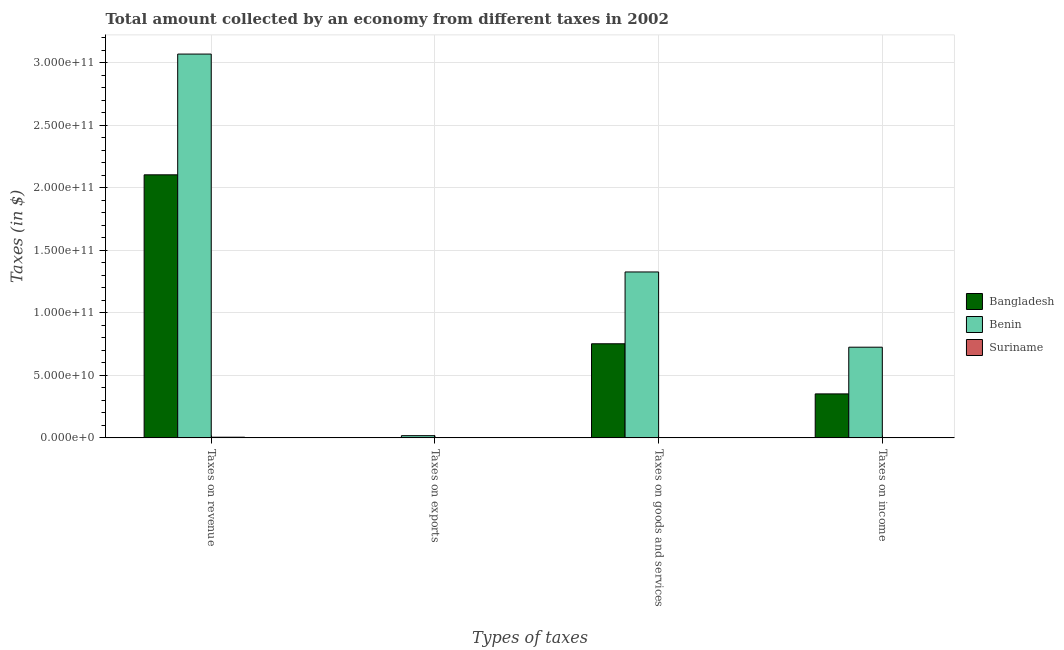How many different coloured bars are there?
Provide a short and direct response. 3. How many groups of bars are there?
Provide a succinct answer. 4. Are the number of bars per tick equal to the number of legend labels?
Your answer should be very brief. Yes. Are the number of bars on each tick of the X-axis equal?
Your response must be concise. Yes. How many bars are there on the 4th tick from the left?
Provide a succinct answer. 3. How many bars are there on the 4th tick from the right?
Provide a succinct answer. 3. What is the label of the 1st group of bars from the left?
Provide a succinct answer. Taxes on revenue. What is the amount collected as tax on income in Benin?
Give a very brief answer. 7.25e+1. Across all countries, what is the maximum amount collected as tax on goods?
Offer a terse response. 1.33e+11. Across all countries, what is the minimum amount collected as tax on goods?
Keep it short and to the point. 1.86e+08. In which country was the amount collected as tax on exports maximum?
Make the answer very short. Benin. In which country was the amount collected as tax on income minimum?
Offer a terse response. Suriname. What is the total amount collected as tax on goods in the graph?
Provide a succinct answer. 2.08e+11. What is the difference between the amount collected as tax on revenue in Suriname and that in Benin?
Keep it short and to the point. -3.06e+11. What is the difference between the amount collected as tax on goods in Bangladesh and the amount collected as tax on exports in Suriname?
Your answer should be very brief. 7.52e+1. What is the average amount collected as tax on exports per country?
Offer a terse response. 5.90e+08. What is the difference between the amount collected as tax on goods and amount collected as tax on income in Suriname?
Offer a very short reply. -3.04e+06. In how many countries, is the amount collected as tax on exports greater than 300000000000 $?
Your answer should be very brief. 0. What is the ratio of the amount collected as tax on goods in Bangladesh to that in Suriname?
Your answer should be very brief. 404.92. Is the difference between the amount collected as tax on goods in Suriname and Benin greater than the difference between the amount collected as tax on revenue in Suriname and Benin?
Offer a terse response. Yes. What is the difference between the highest and the second highest amount collected as tax on income?
Offer a terse response. 3.73e+1. What is the difference between the highest and the lowest amount collected as tax on income?
Give a very brief answer. 7.23e+1. Is it the case that in every country, the sum of the amount collected as tax on goods and amount collected as tax on revenue is greater than the sum of amount collected as tax on income and amount collected as tax on exports?
Make the answer very short. No. What does the 3rd bar from the left in Taxes on income represents?
Offer a very short reply. Suriname. What does the 1st bar from the right in Taxes on income represents?
Give a very brief answer. Suriname. How many bars are there?
Ensure brevity in your answer.  12. Are all the bars in the graph horizontal?
Your answer should be very brief. No. What is the difference between two consecutive major ticks on the Y-axis?
Your answer should be very brief. 5.00e+1. Are the values on the major ticks of Y-axis written in scientific E-notation?
Ensure brevity in your answer.  Yes. How are the legend labels stacked?
Keep it short and to the point. Vertical. What is the title of the graph?
Your answer should be very brief. Total amount collected by an economy from different taxes in 2002. What is the label or title of the X-axis?
Your answer should be very brief. Types of taxes. What is the label or title of the Y-axis?
Offer a very short reply. Taxes (in $). What is the Taxes (in $) of Bangladesh in Taxes on revenue?
Ensure brevity in your answer.  2.10e+11. What is the Taxes (in $) in Benin in Taxes on revenue?
Provide a short and direct response. 3.07e+11. What is the Taxes (in $) of Suriname in Taxes on revenue?
Your answer should be very brief. 5.24e+08. What is the Taxes (in $) in Benin in Taxes on exports?
Your response must be concise. 1.77e+09. What is the Taxes (in $) of Suriname in Taxes on exports?
Your answer should be very brief. 4.93e+06. What is the Taxes (in $) in Bangladesh in Taxes on goods and services?
Provide a succinct answer. 7.52e+1. What is the Taxes (in $) in Benin in Taxes on goods and services?
Make the answer very short. 1.33e+11. What is the Taxes (in $) of Suriname in Taxes on goods and services?
Your answer should be very brief. 1.86e+08. What is the Taxes (in $) in Bangladesh in Taxes on income?
Provide a succinct answer. 3.52e+1. What is the Taxes (in $) in Benin in Taxes on income?
Keep it short and to the point. 7.25e+1. What is the Taxes (in $) in Suriname in Taxes on income?
Offer a terse response. 1.89e+08. Across all Types of taxes, what is the maximum Taxes (in $) of Bangladesh?
Offer a terse response. 2.10e+11. Across all Types of taxes, what is the maximum Taxes (in $) of Benin?
Provide a short and direct response. 3.07e+11. Across all Types of taxes, what is the maximum Taxes (in $) in Suriname?
Your answer should be very brief. 5.24e+08. Across all Types of taxes, what is the minimum Taxes (in $) of Bangladesh?
Offer a terse response. 10000. Across all Types of taxes, what is the minimum Taxes (in $) in Benin?
Provide a succinct answer. 1.77e+09. Across all Types of taxes, what is the minimum Taxes (in $) of Suriname?
Offer a terse response. 4.93e+06. What is the total Taxes (in $) of Bangladesh in the graph?
Keep it short and to the point. 3.21e+11. What is the total Taxes (in $) of Benin in the graph?
Your response must be concise. 5.14e+11. What is the total Taxes (in $) in Suriname in the graph?
Offer a terse response. 9.04e+08. What is the difference between the Taxes (in $) of Bangladesh in Taxes on revenue and that in Taxes on exports?
Ensure brevity in your answer.  2.10e+11. What is the difference between the Taxes (in $) of Benin in Taxes on revenue and that in Taxes on exports?
Provide a succinct answer. 3.05e+11. What is the difference between the Taxes (in $) in Suriname in Taxes on revenue and that in Taxes on exports?
Provide a short and direct response. 5.19e+08. What is the difference between the Taxes (in $) of Bangladesh in Taxes on revenue and that in Taxes on goods and services?
Ensure brevity in your answer.  1.35e+11. What is the difference between the Taxes (in $) of Benin in Taxes on revenue and that in Taxes on goods and services?
Give a very brief answer. 1.74e+11. What is the difference between the Taxes (in $) of Suriname in Taxes on revenue and that in Taxes on goods and services?
Keep it short and to the point. 3.38e+08. What is the difference between the Taxes (in $) in Bangladesh in Taxes on revenue and that in Taxes on income?
Offer a terse response. 1.75e+11. What is the difference between the Taxes (in $) of Benin in Taxes on revenue and that in Taxes on income?
Make the answer very short. 2.34e+11. What is the difference between the Taxes (in $) in Suriname in Taxes on revenue and that in Taxes on income?
Your answer should be compact. 3.35e+08. What is the difference between the Taxes (in $) of Bangladesh in Taxes on exports and that in Taxes on goods and services?
Your response must be concise. -7.52e+1. What is the difference between the Taxes (in $) in Benin in Taxes on exports and that in Taxes on goods and services?
Your response must be concise. -1.31e+11. What is the difference between the Taxes (in $) of Suriname in Taxes on exports and that in Taxes on goods and services?
Offer a terse response. -1.81e+08. What is the difference between the Taxes (in $) in Bangladesh in Taxes on exports and that in Taxes on income?
Your answer should be very brief. -3.52e+1. What is the difference between the Taxes (in $) in Benin in Taxes on exports and that in Taxes on income?
Provide a succinct answer. -7.07e+1. What is the difference between the Taxes (in $) of Suriname in Taxes on exports and that in Taxes on income?
Provide a short and direct response. -1.84e+08. What is the difference between the Taxes (in $) in Bangladesh in Taxes on goods and services and that in Taxes on income?
Your response must be concise. 4.01e+1. What is the difference between the Taxes (in $) of Benin in Taxes on goods and services and that in Taxes on income?
Your answer should be very brief. 6.01e+1. What is the difference between the Taxes (in $) in Suriname in Taxes on goods and services and that in Taxes on income?
Provide a short and direct response. -3.04e+06. What is the difference between the Taxes (in $) in Bangladesh in Taxes on revenue and the Taxes (in $) in Benin in Taxes on exports?
Give a very brief answer. 2.09e+11. What is the difference between the Taxes (in $) of Bangladesh in Taxes on revenue and the Taxes (in $) of Suriname in Taxes on exports?
Your answer should be very brief. 2.10e+11. What is the difference between the Taxes (in $) of Benin in Taxes on revenue and the Taxes (in $) of Suriname in Taxes on exports?
Your response must be concise. 3.07e+11. What is the difference between the Taxes (in $) in Bangladesh in Taxes on revenue and the Taxes (in $) in Benin in Taxes on goods and services?
Offer a terse response. 7.77e+1. What is the difference between the Taxes (in $) in Bangladesh in Taxes on revenue and the Taxes (in $) in Suriname in Taxes on goods and services?
Offer a terse response. 2.10e+11. What is the difference between the Taxes (in $) in Benin in Taxes on revenue and the Taxes (in $) in Suriname in Taxes on goods and services?
Provide a succinct answer. 3.07e+11. What is the difference between the Taxes (in $) of Bangladesh in Taxes on revenue and the Taxes (in $) of Benin in Taxes on income?
Provide a succinct answer. 1.38e+11. What is the difference between the Taxes (in $) of Bangladesh in Taxes on revenue and the Taxes (in $) of Suriname in Taxes on income?
Offer a terse response. 2.10e+11. What is the difference between the Taxes (in $) of Benin in Taxes on revenue and the Taxes (in $) of Suriname in Taxes on income?
Offer a terse response. 3.07e+11. What is the difference between the Taxes (in $) in Bangladesh in Taxes on exports and the Taxes (in $) in Benin in Taxes on goods and services?
Your response must be concise. -1.33e+11. What is the difference between the Taxes (in $) of Bangladesh in Taxes on exports and the Taxes (in $) of Suriname in Taxes on goods and services?
Provide a succinct answer. -1.86e+08. What is the difference between the Taxes (in $) of Benin in Taxes on exports and the Taxes (in $) of Suriname in Taxes on goods and services?
Provide a succinct answer. 1.58e+09. What is the difference between the Taxes (in $) in Bangladesh in Taxes on exports and the Taxes (in $) in Benin in Taxes on income?
Make the answer very short. -7.25e+1. What is the difference between the Taxes (in $) of Bangladesh in Taxes on exports and the Taxes (in $) of Suriname in Taxes on income?
Ensure brevity in your answer.  -1.89e+08. What is the difference between the Taxes (in $) in Benin in Taxes on exports and the Taxes (in $) in Suriname in Taxes on income?
Your response must be concise. 1.58e+09. What is the difference between the Taxes (in $) of Bangladesh in Taxes on goods and services and the Taxes (in $) of Benin in Taxes on income?
Provide a succinct answer. 2.73e+09. What is the difference between the Taxes (in $) of Bangladesh in Taxes on goods and services and the Taxes (in $) of Suriname in Taxes on income?
Ensure brevity in your answer.  7.50e+1. What is the difference between the Taxes (in $) of Benin in Taxes on goods and services and the Taxes (in $) of Suriname in Taxes on income?
Your answer should be compact. 1.32e+11. What is the average Taxes (in $) in Bangladesh per Types of taxes?
Offer a very short reply. 8.02e+1. What is the average Taxes (in $) in Benin per Types of taxes?
Offer a terse response. 1.28e+11. What is the average Taxes (in $) of Suriname per Types of taxes?
Offer a terse response. 2.26e+08. What is the difference between the Taxes (in $) in Bangladesh and Taxes (in $) in Benin in Taxes on revenue?
Keep it short and to the point. -9.65e+1. What is the difference between the Taxes (in $) in Bangladesh and Taxes (in $) in Suriname in Taxes on revenue?
Your answer should be compact. 2.10e+11. What is the difference between the Taxes (in $) in Benin and Taxes (in $) in Suriname in Taxes on revenue?
Your answer should be compact. 3.06e+11. What is the difference between the Taxes (in $) in Bangladesh and Taxes (in $) in Benin in Taxes on exports?
Your response must be concise. -1.77e+09. What is the difference between the Taxes (in $) in Bangladesh and Taxes (in $) in Suriname in Taxes on exports?
Ensure brevity in your answer.  -4.92e+06. What is the difference between the Taxes (in $) of Benin and Taxes (in $) of Suriname in Taxes on exports?
Your response must be concise. 1.76e+09. What is the difference between the Taxes (in $) in Bangladesh and Taxes (in $) in Benin in Taxes on goods and services?
Make the answer very short. -5.74e+1. What is the difference between the Taxes (in $) of Bangladesh and Taxes (in $) of Suriname in Taxes on goods and services?
Your answer should be compact. 7.50e+1. What is the difference between the Taxes (in $) in Benin and Taxes (in $) in Suriname in Taxes on goods and services?
Keep it short and to the point. 1.32e+11. What is the difference between the Taxes (in $) of Bangladesh and Taxes (in $) of Benin in Taxes on income?
Your answer should be very brief. -3.73e+1. What is the difference between the Taxes (in $) of Bangladesh and Taxes (in $) of Suriname in Taxes on income?
Ensure brevity in your answer.  3.50e+1. What is the difference between the Taxes (in $) of Benin and Taxes (in $) of Suriname in Taxes on income?
Make the answer very short. 7.23e+1. What is the ratio of the Taxes (in $) in Bangladesh in Taxes on revenue to that in Taxes on exports?
Your answer should be compact. 2.10e+07. What is the ratio of the Taxes (in $) in Benin in Taxes on revenue to that in Taxes on exports?
Your answer should be compact. 173.83. What is the ratio of the Taxes (in $) in Suriname in Taxes on revenue to that in Taxes on exports?
Provide a succinct answer. 106.28. What is the ratio of the Taxes (in $) in Bangladesh in Taxes on revenue to that in Taxes on goods and services?
Offer a terse response. 2.8. What is the ratio of the Taxes (in $) in Benin in Taxes on revenue to that in Taxes on goods and services?
Your response must be concise. 2.31. What is the ratio of the Taxes (in $) in Suriname in Taxes on revenue to that in Taxes on goods and services?
Your response must be concise. 2.82. What is the ratio of the Taxes (in $) of Bangladesh in Taxes on revenue to that in Taxes on income?
Your answer should be compact. 5.98. What is the ratio of the Taxes (in $) in Benin in Taxes on revenue to that in Taxes on income?
Your response must be concise. 4.23. What is the ratio of the Taxes (in $) in Suriname in Taxes on revenue to that in Taxes on income?
Give a very brief answer. 2.78. What is the ratio of the Taxes (in $) in Bangladesh in Taxes on exports to that in Taxes on goods and services?
Offer a terse response. 0. What is the ratio of the Taxes (in $) of Benin in Taxes on exports to that in Taxes on goods and services?
Provide a succinct answer. 0.01. What is the ratio of the Taxes (in $) of Suriname in Taxes on exports to that in Taxes on goods and services?
Offer a terse response. 0.03. What is the ratio of the Taxes (in $) of Bangladesh in Taxes on exports to that in Taxes on income?
Your response must be concise. 0. What is the ratio of the Taxes (in $) of Benin in Taxes on exports to that in Taxes on income?
Make the answer very short. 0.02. What is the ratio of the Taxes (in $) of Suriname in Taxes on exports to that in Taxes on income?
Offer a very short reply. 0.03. What is the ratio of the Taxes (in $) in Bangladesh in Taxes on goods and services to that in Taxes on income?
Your response must be concise. 2.14. What is the ratio of the Taxes (in $) in Benin in Taxes on goods and services to that in Taxes on income?
Keep it short and to the point. 1.83. What is the ratio of the Taxes (in $) of Suriname in Taxes on goods and services to that in Taxes on income?
Keep it short and to the point. 0.98. What is the difference between the highest and the second highest Taxes (in $) in Bangladesh?
Provide a short and direct response. 1.35e+11. What is the difference between the highest and the second highest Taxes (in $) of Benin?
Your answer should be compact. 1.74e+11. What is the difference between the highest and the second highest Taxes (in $) in Suriname?
Make the answer very short. 3.35e+08. What is the difference between the highest and the lowest Taxes (in $) of Bangladesh?
Offer a very short reply. 2.10e+11. What is the difference between the highest and the lowest Taxes (in $) in Benin?
Give a very brief answer. 3.05e+11. What is the difference between the highest and the lowest Taxes (in $) in Suriname?
Your answer should be very brief. 5.19e+08. 